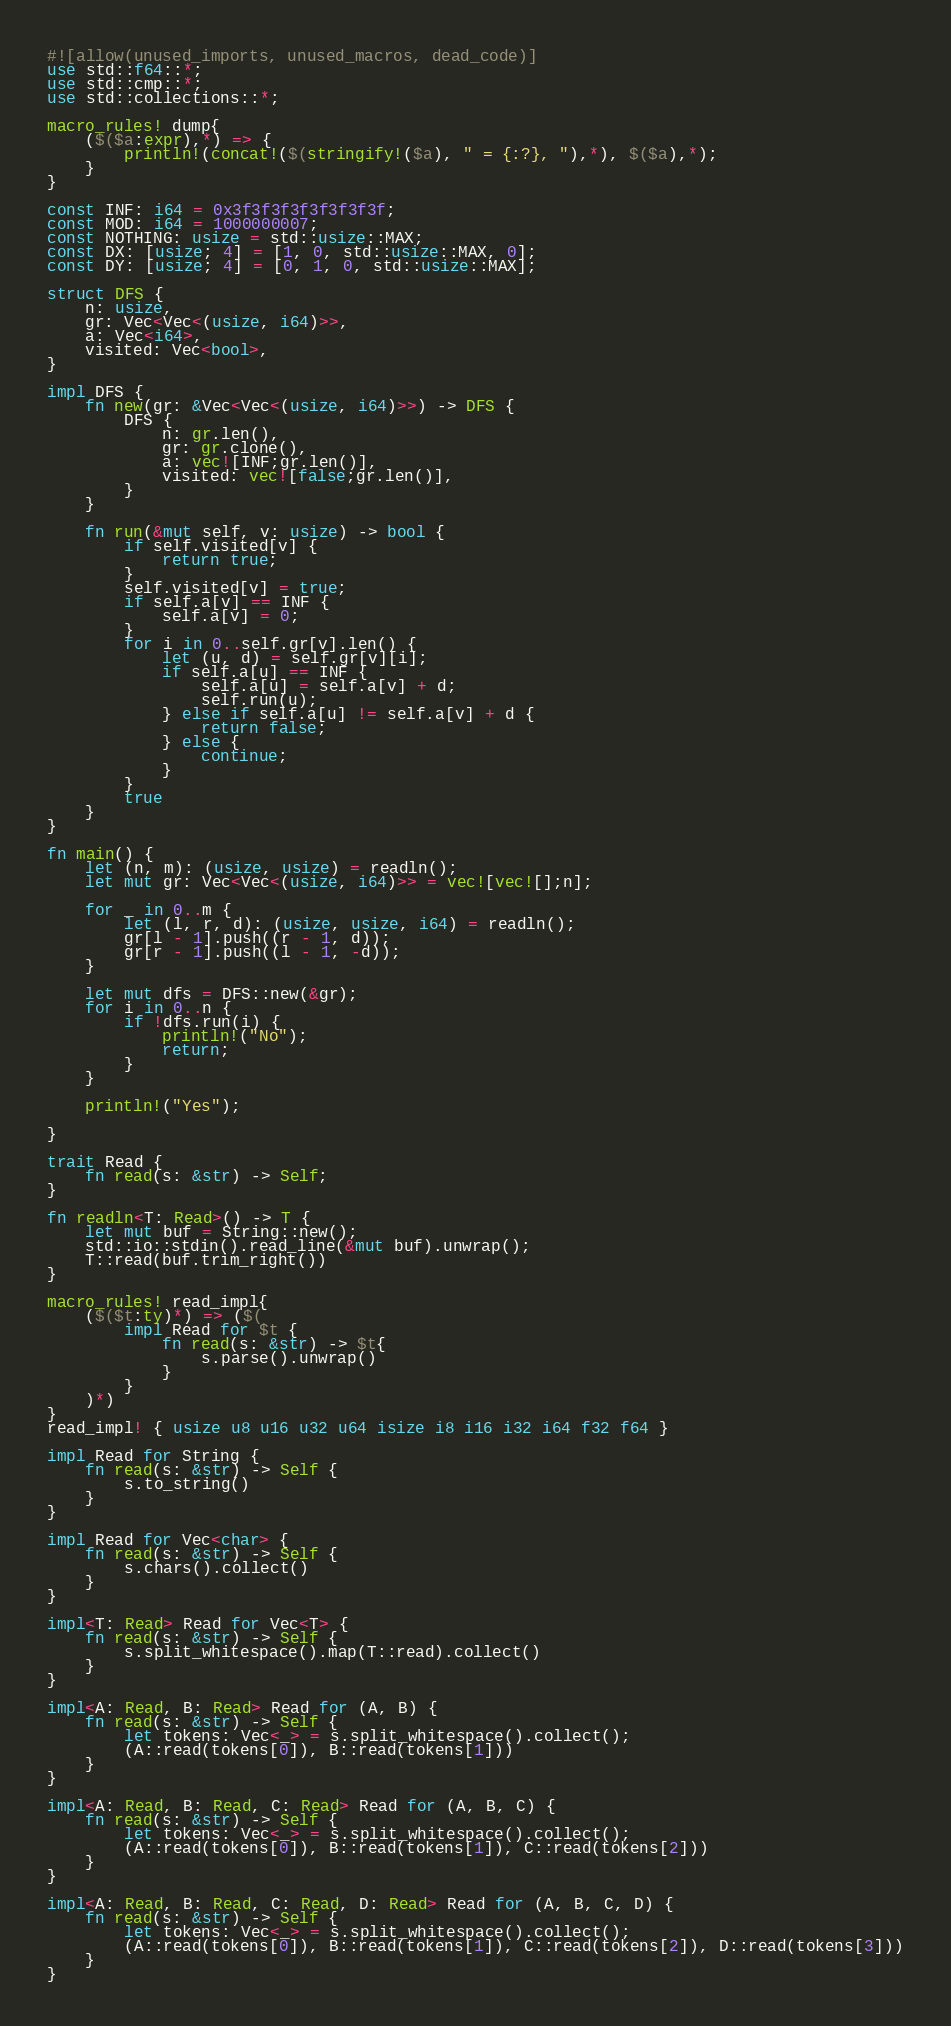<code> <loc_0><loc_0><loc_500><loc_500><_Rust_>#![allow(unused_imports, unused_macros, dead_code)]
use std::f64::*;
use std::cmp::*;
use std::collections::*;

macro_rules! dump{
    ($($a:expr),*) => {
        println!(concat!($(stringify!($a), " = {:?}, "),*), $($a),*);
    }
}

const INF: i64 = 0x3f3f3f3f3f3f3f3f;
const MOD: i64 = 1000000007;
const NOTHING: usize = std::usize::MAX;
const DX: [usize; 4] = [1, 0, std::usize::MAX, 0];
const DY: [usize; 4] = [0, 1, 0, std::usize::MAX];

struct DFS {
    n: usize,
    gr: Vec<Vec<(usize, i64)>>,
    a: Vec<i64>,
    visited: Vec<bool>,
}

impl DFS {
    fn new(gr: &Vec<Vec<(usize, i64)>>) -> DFS {
        DFS {
            n: gr.len(),
            gr: gr.clone(),
            a: vec![INF;gr.len()],
            visited: vec![false;gr.len()],
        }
    }

    fn run(&mut self, v: usize) -> bool {
        if self.visited[v] {
            return true;
        }
        self.visited[v] = true;
        if self.a[v] == INF {
            self.a[v] = 0;
        }
        for i in 0..self.gr[v].len() {
            let (u, d) = self.gr[v][i];
            if self.a[u] == INF {
                self.a[u] = self.a[v] + d;
                self.run(u);
            } else if self.a[u] != self.a[v] + d {
                return false;
            } else {
                continue;
            }
        }
        true
    }
}

fn main() {
    let (n, m): (usize, usize) = readln();
    let mut gr: Vec<Vec<(usize, i64)>> = vec![vec![];n];

    for _ in 0..m {
        let (l, r, d): (usize, usize, i64) = readln();
        gr[l - 1].push((r - 1, d));
        gr[r - 1].push((l - 1, -d));
    }

    let mut dfs = DFS::new(&gr);
    for i in 0..n {
        if !dfs.run(i) {
            println!("No");
            return;
        }
    }

    println!("Yes");

}

trait Read {
    fn read(s: &str) -> Self;
}

fn readln<T: Read>() -> T {
    let mut buf = String::new();
    std::io::stdin().read_line(&mut buf).unwrap();
    T::read(buf.trim_right())
}

macro_rules! read_impl{
    ($($t:ty)*) => ($(
        impl Read for $t {
            fn read(s: &str) -> $t{
                s.parse().unwrap()
            }
        }
    )*)
}
read_impl! { usize u8 u16 u32 u64 isize i8 i16 i32 i64 f32 f64 }

impl Read for String {
    fn read(s: &str) -> Self {
        s.to_string()
    }
}

impl Read for Vec<char> {
    fn read(s: &str) -> Self {
        s.chars().collect()
    }
}

impl<T: Read> Read for Vec<T> {
    fn read(s: &str) -> Self {
        s.split_whitespace().map(T::read).collect()
    }
}

impl<A: Read, B: Read> Read for (A, B) {
    fn read(s: &str) -> Self {
        let tokens: Vec<_> = s.split_whitespace().collect();
        (A::read(tokens[0]), B::read(tokens[1]))
    }
}

impl<A: Read, B: Read, C: Read> Read for (A, B, C) {
    fn read(s: &str) -> Self {
        let tokens: Vec<_> = s.split_whitespace().collect();
        (A::read(tokens[0]), B::read(tokens[1]), C::read(tokens[2]))
    }
}

impl<A: Read, B: Read, C: Read, D: Read> Read for (A, B, C, D) {
    fn read(s: &str) -> Self {
        let tokens: Vec<_> = s.split_whitespace().collect();
        (A::read(tokens[0]), B::read(tokens[1]), C::read(tokens[2]), D::read(tokens[3]))
    }
}
</code> 